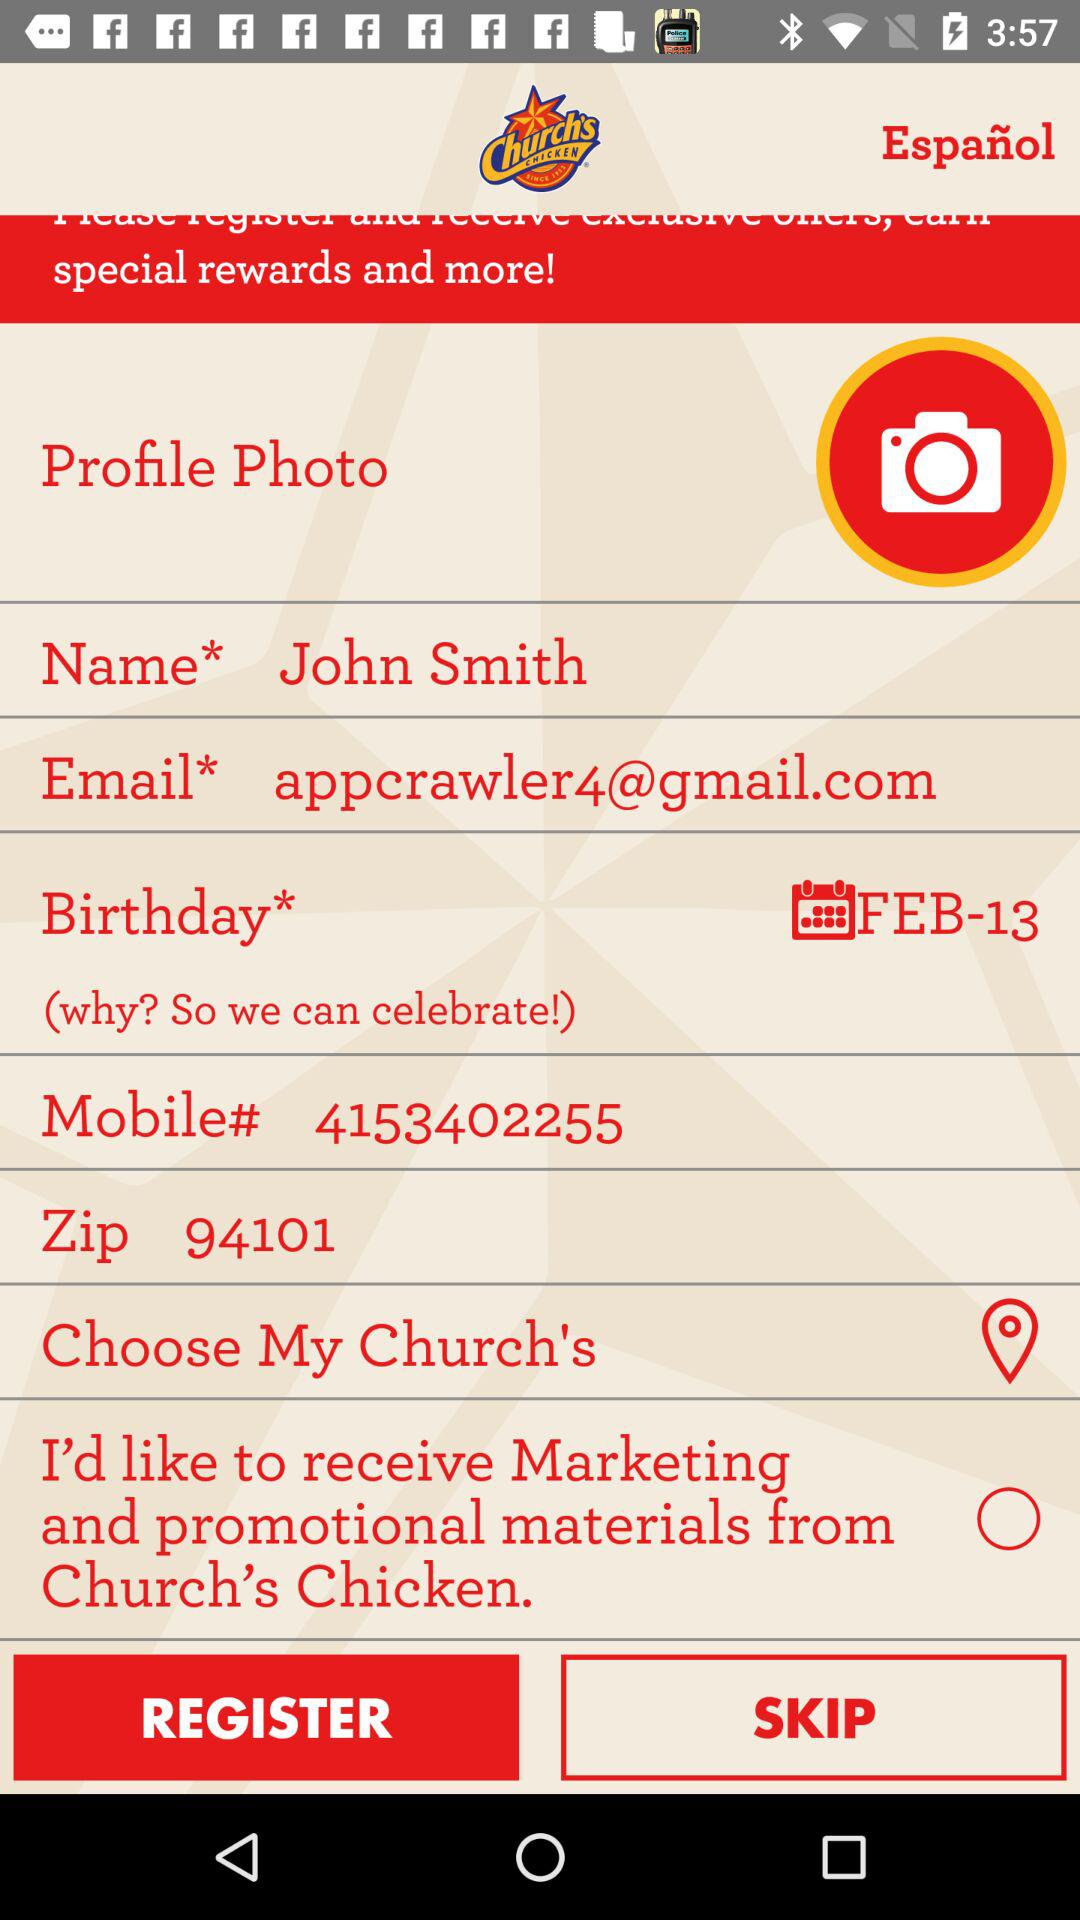What is the user name? The user name is John Smith. 